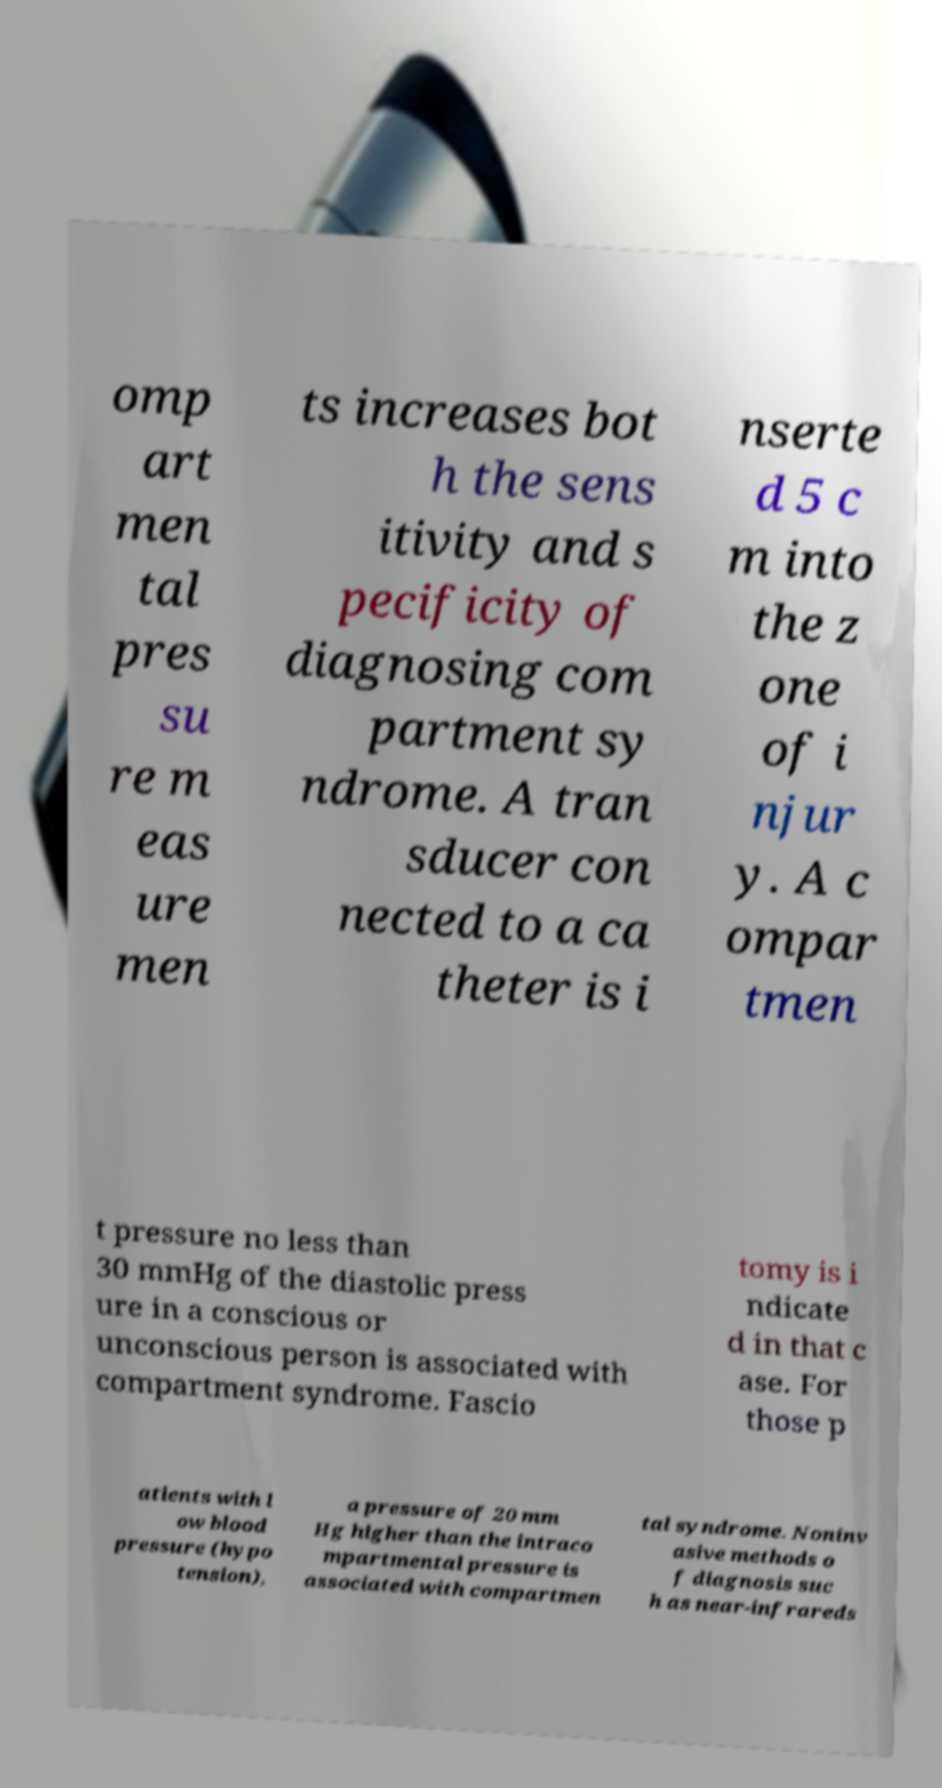Can you accurately transcribe the text from the provided image for me? omp art men tal pres su re m eas ure men ts increases bot h the sens itivity and s pecificity of diagnosing com partment sy ndrome. A tran sducer con nected to a ca theter is i nserte d 5 c m into the z one of i njur y. A c ompar tmen t pressure no less than 30 mmHg of the diastolic press ure in a conscious or unconscious person is associated with compartment syndrome. Fascio tomy is i ndicate d in that c ase. For those p atients with l ow blood pressure (hypo tension), a pressure of 20 mm Hg higher than the intraco mpartmental pressure is associated with compartmen tal syndrome. Noninv asive methods o f diagnosis suc h as near-infrareds 